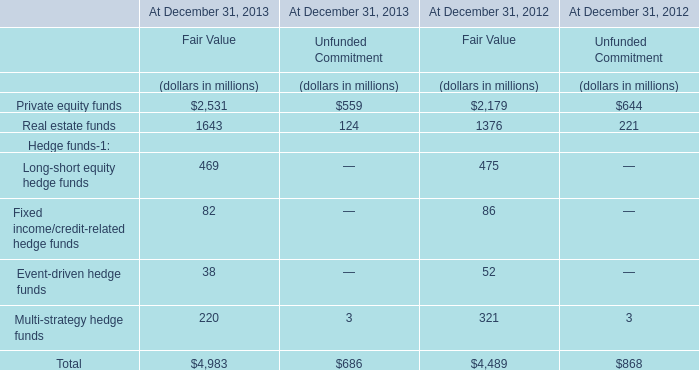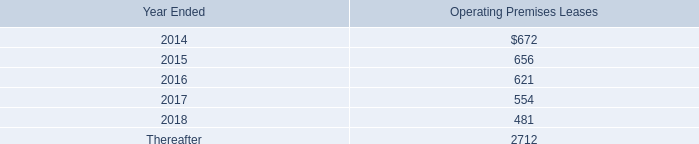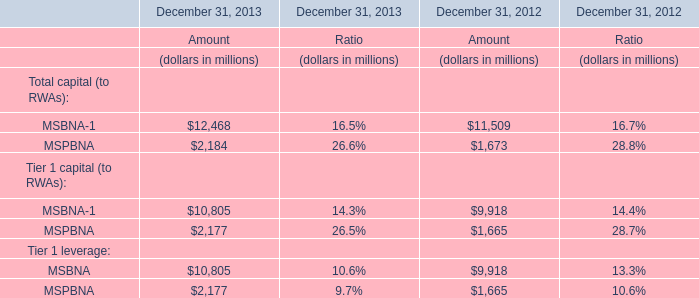What's the total amount of the MSBNA-1 for Amount in the years where Private equity funds for Fair Value is greater than 2000? 
Computations: (12468 + 11509)
Answer: 23977.0. 